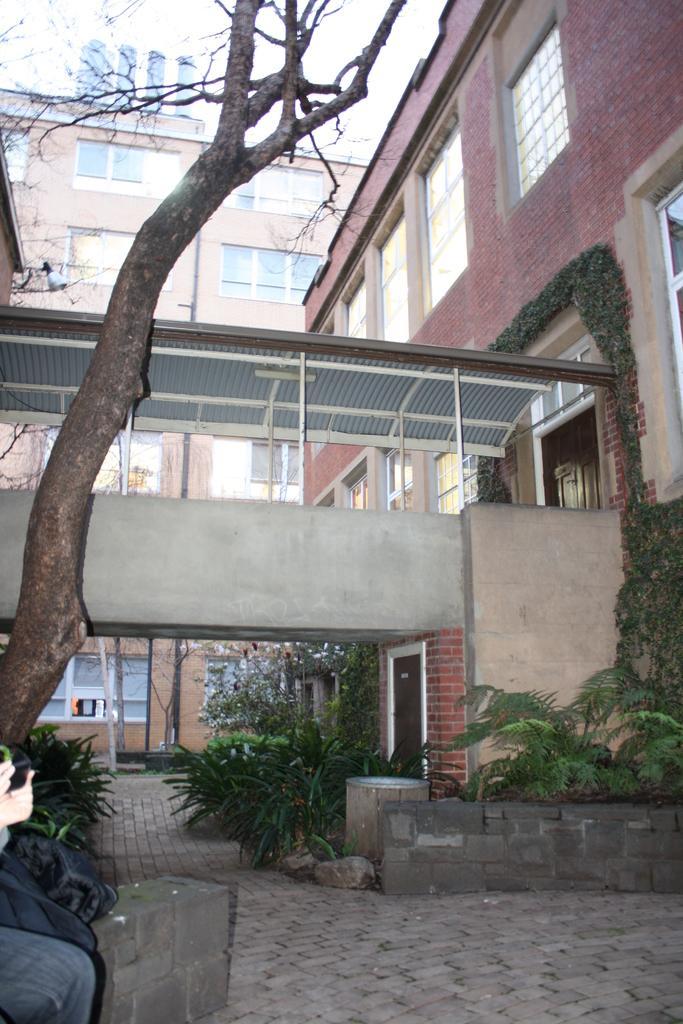Could you give a brief overview of what you see in this image? In this picture we can observe some plants. There is a tree on the left side. We can observe some buildings. On the left side there is a person sitting. In the background there is a sky. 